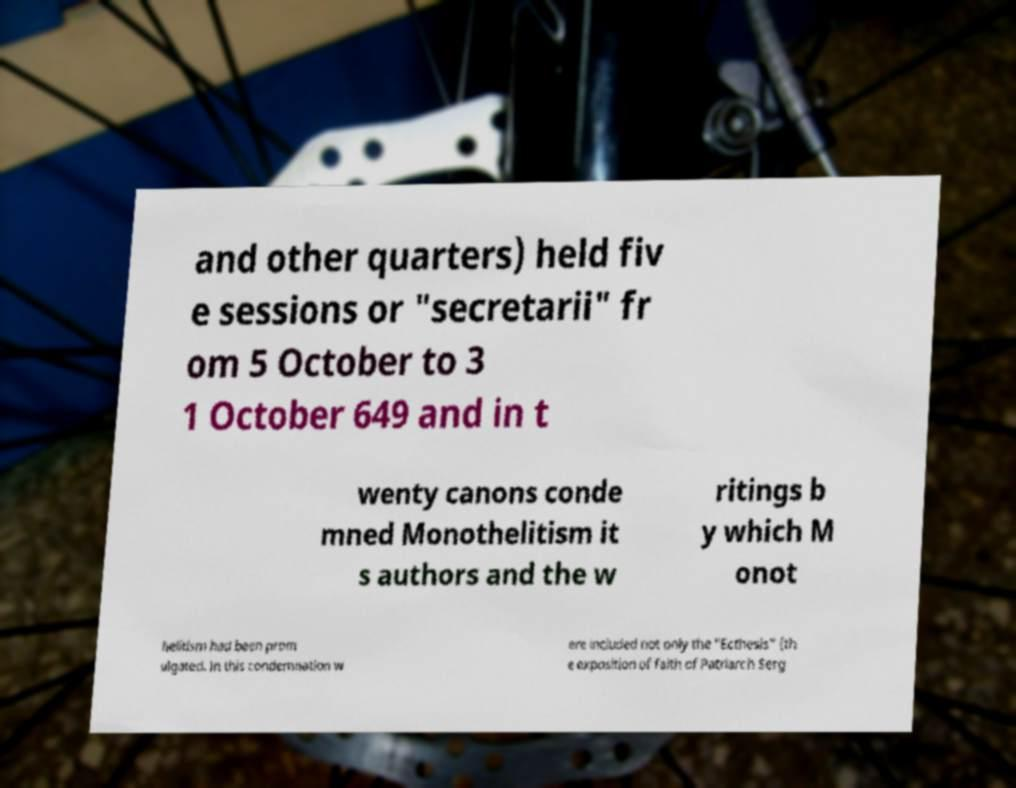Could you assist in decoding the text presented in this image and type it out clearly? and other quarters) held fiv e sessions or "secretarii" fr om 5 October to 3 1 October 649 and in t wenty canons conde mned Monothelitism it s authors and the w ritings b y which M onot helitism had been prom ulgated. In this condemnation w ere included not only the "Ecthesis" (th e exposition of faith of Patriarch Serg 